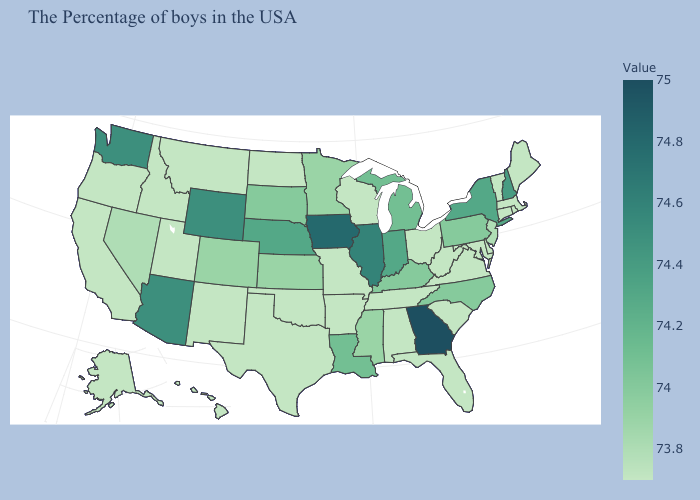Among the states that border Colorado , which have the lowest value?
Quick response, please. Oklahoma, New Mexico, Utah. Among the states that border Colorado , does Nebraska have the lowest value?
Short answer required. No. Among the states that border New Jersey , which have the highest value?
Concise answer only. New York. 